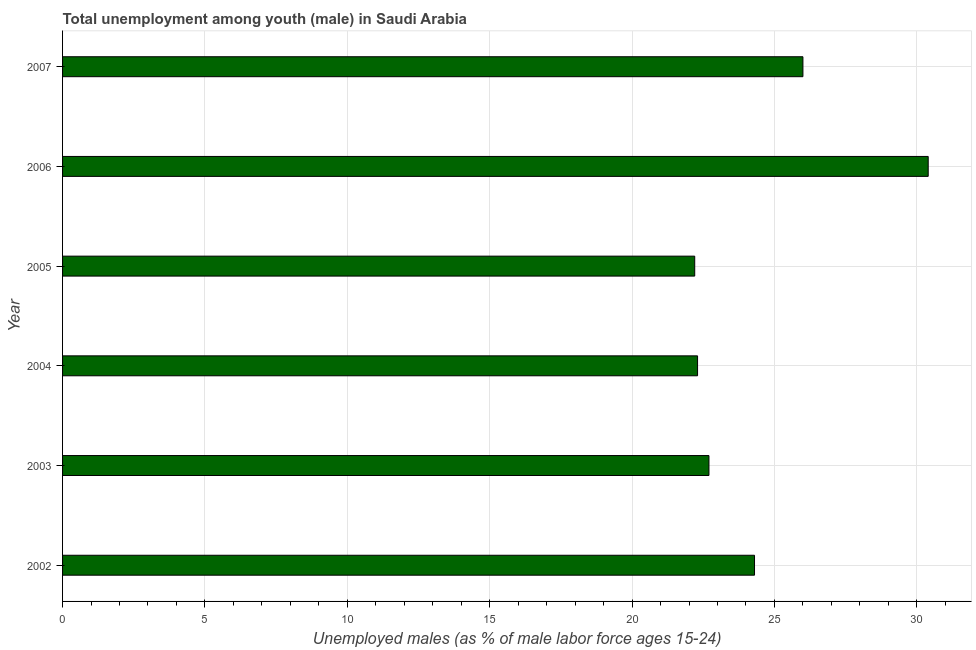What is the title of the graph?
Make the answer very short. Total unemployment among youth (male) in Saudi Arabia. What is the label or title of the X-axis?
Give a very brief answer. Unemployed males (as % of male labor force ages 15-24). What is the unemployed male youth population in 2005?
Keep it short and to the point. 22.2. Across all years, what is the maximum unemployed male youth population?
Offer a terse response. 30.4. Across all years, what is the minimum unemployed male youth population?
Provide a succinct answer. 22.2. In which year was the unemployed male youth population maximum?
Offer a terse response. 2006. In which year was the unemployed male youth population minimum?
Ensure brevity in your answer.  2005. What is the sum of the unemployed male youth population?
Provide a short and direct response. 147.9. What is the average unemployed male youth population per year?
Your response must be concise. 24.65. What is the median unemployed male youth population?
Offer a terse response. 23.5. Do a majority of the years between 2007 and 2005 (inclusive) have unemployed male youth population greater than 8 %?
Offer a very short reply. Yes. What is the ratio of the unemployed male youth population in 2006 to that in 2007?
Your answer should be very brief. 1.17. Is the unemployed male youth population in 2003 less than that in 2007?
Your answer should be very brief. Yes. What is the difference between the highest and the second highest unemployed male youth population?
Give a very brief answer. 4.4. In how many years, is the unemployed male youth population greater than the average unemployed male youth population taken over all years?
Give a very brief answer. 2. Are all the bars in the graph horizontal?
Make the answer very short. Yes. What is the difference between two consecutive major ticks on the X-axis?
Your answer should be compact. 5. What is the Unemployed males (as % of male labor force ages 15-24) of 2002?
Provide a succinct answer. 24.3. What is the Unemployed males (as % of male labor force ages 15-24) of 2003?
Make the answer very short. 22.7. What is the Unemployed males (as % of male labor force ages 15-24) of 2004?
Provide a succinct answer. 22.3. What is the Unemployed males (as % of male labor force ages 15-24) of 2005?
Provide a short and direct response. 22.2. What is the Unemployed males (as % of male labor force ages 15-24) of 2006?
Give a very brief answer. 30.4. What is the difference between the Unemployed males (as % of male labor force ages 15-24) in 2002 and 2003?
Keep it short and to the point. 1.6. What is the difference between the Unemployed males (as % of male labor force ages 15-24) in 2002 and 2004?
Provide a succinct answer. 2. What is the difference between the Unemployed males (as % of male labor force ages 15-24) in 2002 and 2006?
Keep it short and to the point. -6.1. What is the difference between the Unemployed males (as % of male labor force ages 15-24) in 2003 and 2005?
Provide a succinct answer. 0.5. What is the difference between the Unemployed males (as % of male labor force ages 15-24) in 2003 and 2006?
Make the answer very short. -7.7. What is the difference between the Unemployed males (as % of male labor force ages 15-24) in 2003 and 2007?
Offer a terse response. -3.3. What is the difference between the Unemployed males (as % of male labor force ages 15-24) in 2004 and 2005?
Offer a terse response. 0.1. What is the difference between the Unemployed males (as % of male labor force ages 15-24) in 2004 and 2007?
Give a very brief answer. -3.7. What is the difference between the Unemployed males (as % of male labor force ages 15-24) in 2005 and 2006?
Give a very brief answer. -8.2. What is the difference between the Unemployed males (as % of male labor force ages 15-24) in 2006 and 2007?
Offer a very short reply. 4.4. What is the ratio of the Unemployed males (as % of male labor force ages 15-24) in 2002 to that in 2003?
Provide a succinct answer. 1.07. What is the ratio of the Unemployed males (as % of male labor force ages 15-24) in 2002 to that in 2004?
Offer a very short reply. 1.09. What is the ratio of the Unemployed males (as % of male labor force ages 15-24) in 2002 to that in 2005?
Offer a very short reply. 1.09. What is the ratio of the Unemployed males (as % of male labor force ages 15-24) in 2002 to that in 2006?
Your answer should be compact. 0.8. What is the ratio of the Unemployed males (as % of male labor force ages 15-24) in 2002 to that in 2007?
Provide a succinct answer. 0.94. What is the ratio of the Unemployed males (as % of male labor force ages 15-24) in 2003 to that in 2004?
Give a very brief answer. 1.02. What is the ratio of the Unemployed males (as % of male labor force ages 15-24) in 2003 to that in 2006?
Offer a very short reply. 0.75. What is the ratio of the Unemployed males (as % of male labor force ages 15-24) in 2003 to that in 2007?
Give a very brief answer. 0.87. What is the ratio of the Unemployed males (as % of male labor force ages 15-24) in 2004 to that in 2006?
Offer a terse response. 0.73. What is the ratio of the Unemployed males (as % of male labor force ages 15-24) in 2004 to that in 2007?
Your answer should be very brief. 0.86. What is the ratio of the Unemployed males (as % of male labor force ages 15-24) in 2005 to that in 2006?
Offer a terse response. 0.73. What is the ratio of the Unemployed males (as % of male labor force ages 15-24) in 2005 to that in 2007?
Your answer should be very brief. 0.85. What is the ratio of the Unemployed males (as % of male labor force ages 15-24) in 2006 to that in 2007?
Provide a short and direct response. 1.17. 